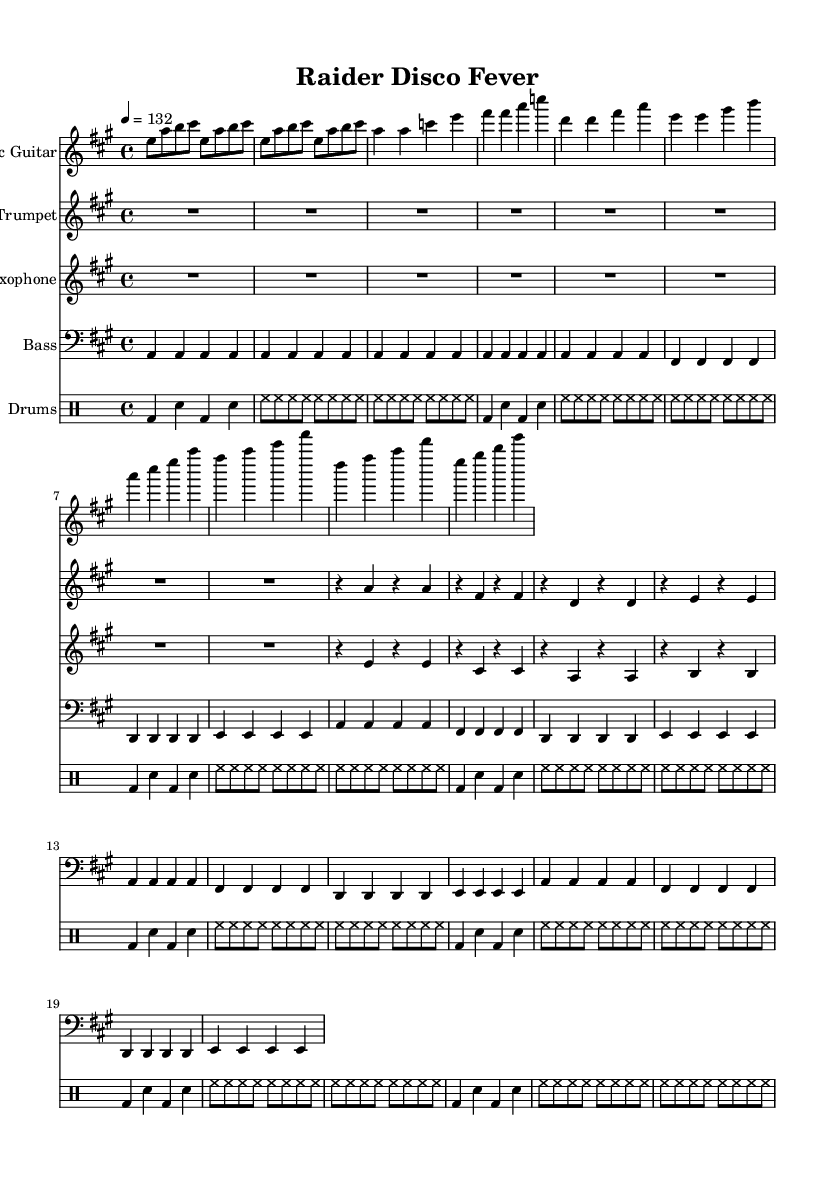What is the key signature of this music? The key signature is A major, which has three sharps: F sharp, C sharp, and G sharp.
Answer: A major What is the time signature of this music? The time signature is shown at the beginning of the staff as 4/4, which indicates four beats per measure and the quarter note receives one beat.
Answer: 4/4 What is the tempo marking of this music? The tempo marking at the start indicates a quarter note equals 132 beats per minute, which specifies the speed of the piece.
Answer: 132 How many measures are in the intro section? The intro section repeats four times, and since each repetition consists of one measure, there are a total of four measures in the intro.
Answer: 4 What type of drum pattern is used in this piece? The sheet indicates a four-on-the-floor pattern, which involves playing the bass drum on every beat. This is typical in disco music.
Answer: Four-on-the-floor What is the rhythmic duration of the first note in the bass guitar part? The first note is an A played as a whole note, indicated by an open note head with no stems or additional markings.
Answer: Whole note In the chorus, what is the highest note played by the trumpet? The highest note played by the trumpet in the chorus is A, which is a higher pitch compared to the other notes being played during that section.
Answer: A 